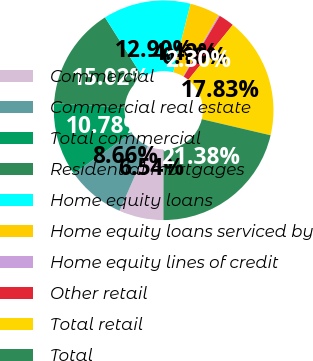Convert chart. <chart><loc_0><loc_0><loc_500><loc_500><pie_chart><fcel>Commercial<fcel>Commercial real estate<fcel>Total commercial<fcel>Residential mortgages<fcel>Home equity loans<fcel>Home equity loans serviced by<fcel>Home equity lines of credit<fcel>Other retail<fcel>Total retail<fcel>Total<nl><fcel>6.54%<fcel>8.66%<fcel>10.78%<fcel>15.02%<fcel>12.9%<fcel>4.42%<fcel>0.18%<fcel>2.3%<fcel>17.83%<fcel>21.38%<nl></chart> 